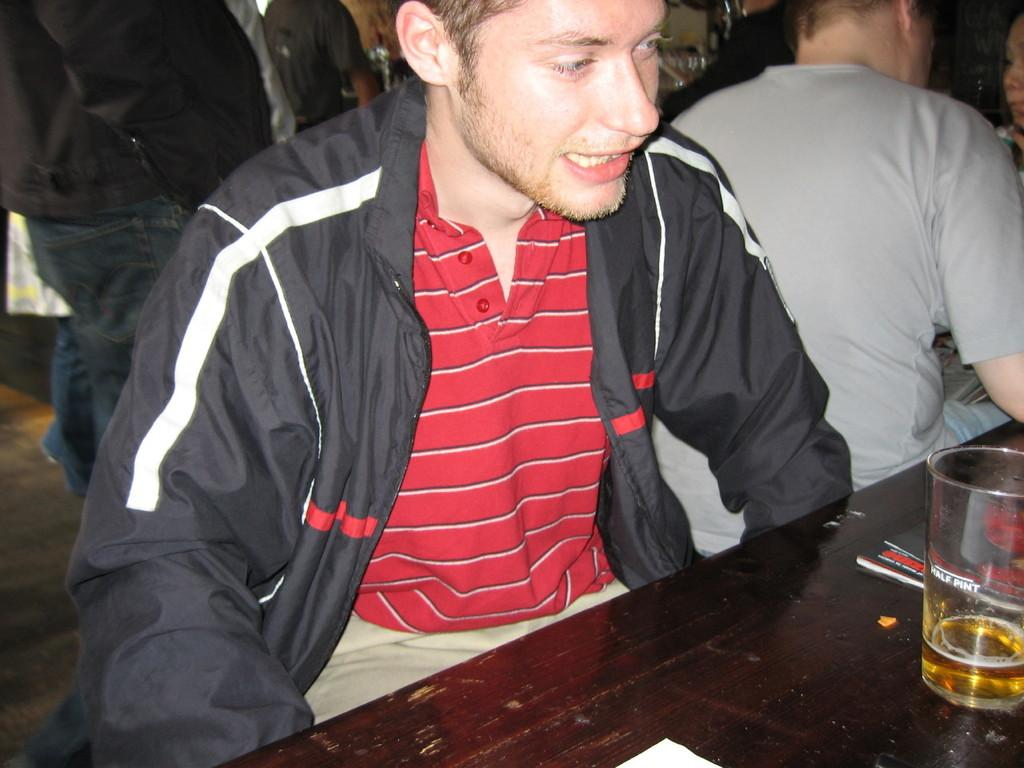What type of surface is visible in the image? There is a floor in the image. What piece of furniture can be seen in the image? There is a table in the image. What type of container is present in the image? There is a glass in the image. Who is present in the image? There are people sitting in the image. What type of cast is visible on the person's leg in the image? There is no cast visible on anyone's leg in the image. What type of party is taking place in the image? There is no indication of a party taking place in the image. 